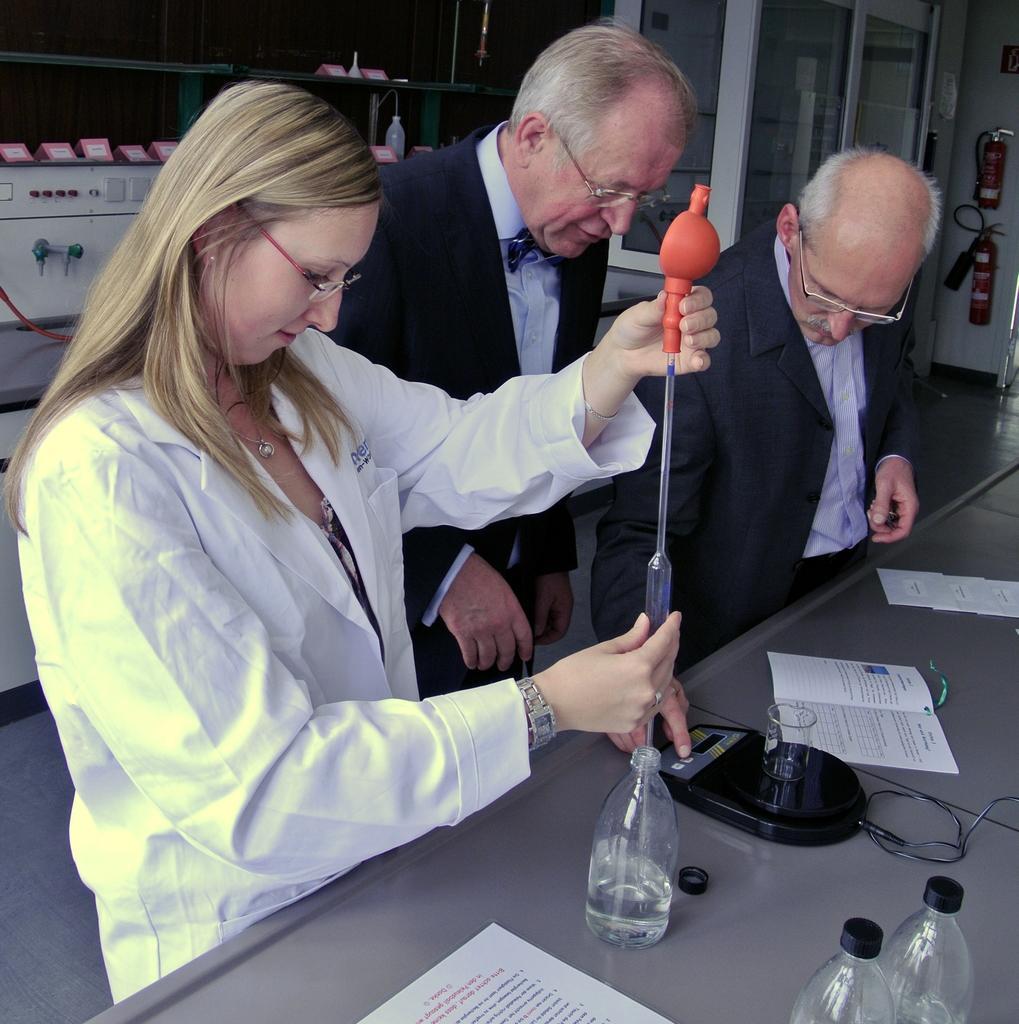Describe this image in one or two sentences. In this image there is a woman putting the glass tube inside the glass bottle. Beside her there are two other people standing. In front of them there is a table. On top of it there are bottles, papers and a few other objects. Behind them there is a machine. On the right side of the image there are fire extinguishers on the wall. 